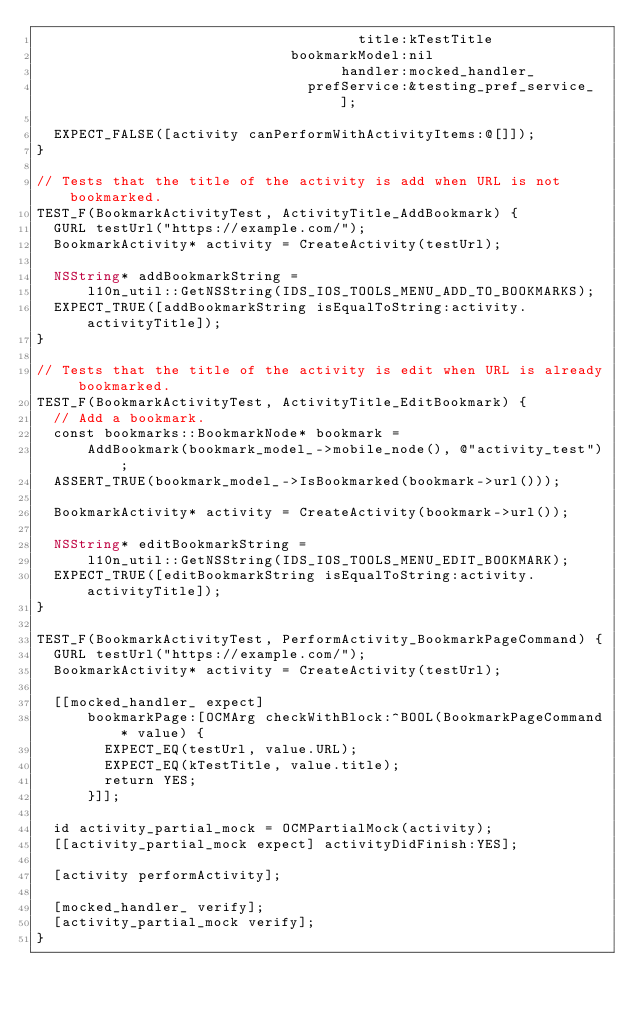<code> <loc_0><loc_0><loc_500><loc_500><_ObjectiveC_>                                      title:kTestTitle
                              bookmarkModel:nil
                                    handler:mocked_handler_
                                prefService:&testing_pref_service_];

  EXPECT_FALSE([activity canPerformWithActivityItems:@[]]);
}

// Tests that the title of the activity is add when URL is not bookmarked.
TEST_F(BookmarkActivityTest, ActivityTitle_AddBookmark) {
  GURL testUrl("https://example.com/");
  BookmarkActivity* activity = CreateActivity(testUrl);

  NSString* addBookmarkString =
      l10n_util::GetNSString(IDS_IOS_TOOLS_MENU_ADD_TO_BOOKMARKS);
  EXPECT_TRUE([addBookmarkString isEqualToString:activity.activityTitle]);
}

// Tests that the title of the activity is edit when URL is already bookmarked.
TEST_F(BookmarkActivityTest, ActivityTitle_EditBookmark) {
  // Add a bookmark.
  const bookmarks::BookmarkNode* bookmark =
      AddBookmark(bookmark_model_->mobile_node(), @"activity_test");
  ASSERT_TRUE(bookmark_model_->IsBookmarked(bookmark->url()));

  BookmarkActivity* activity = CreateActivity(bookmark->url());

  NSString* editBookmarkString =
      l10n_util::GetNSString(IDS_IOS_TOOLS_MENU_EDIT_BOOKMARK);
  EXPECT_TRUE([editBookmarkString isEqualToString:activity.activityTitle]);
}

TEST_F(BookmarkActivityTest, PerformActivity_BookmarkPageCommand) {
  GURL testUrl("https://example.com/");
  BookmarkActivity* activity = CreateActivity(testUrl);

  [[mocked_handler_ expect]
      bookmarkPage:[OCMArg checkWithBlock:^BOOL(BookmarkPageCommand* value) {
        EXPECT_EQ(testUrl, value.URL);
        EXPECT_EQ(kTestTitle, value.title);
        return YES;
      }]];

  id activity_partial_mock = OCMPartialMock(activity);
  [[activity_partial_mock expect] activityDidFinish:YES];

  [activity performActivity];

  [mocked_handler_ verify];
  [activity_partial_mock verify];
}
</code> 